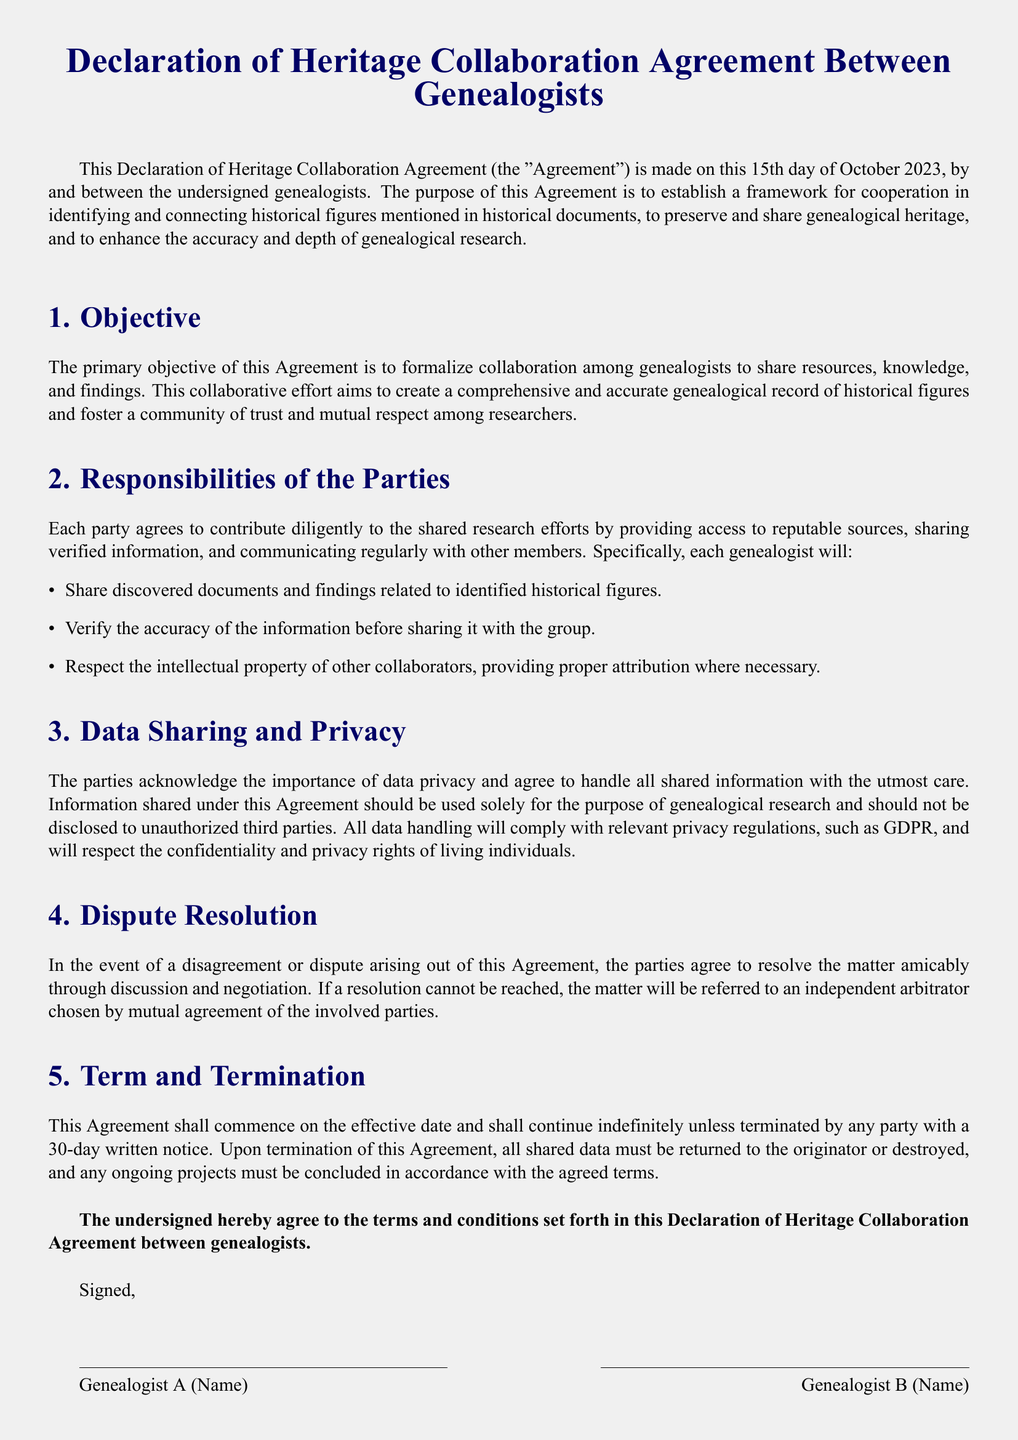What is the date of the Agreement? The date mentioned in the document indicates when the Agreement was made, which is the 15th of October 2023.
Answer: 15th day of October 2023 What is the primary objective of the Agreement? The primary objective as stated in the document is to formalize collaboration among genealogists.
Answer: formalize collaboration among genealogists How many responsibilities are listed under the responsibilities of the parties? The document outlines specific duties that each genealogist must follow, listed as several points.
Answer: three What must be done with shared data upon termination of the Agreement? The document specifies that all shared data must be either returned to the originator or destroyed.
Answer: returned to the originator or destroyed What kind of dispute resolution method is mentioned? The document provides a method for resolving disagreements through a specified process.
Answer: discussion and negotiation Which regulations must data handling comply with? The document notes a specific privacy regulation that must guide data handling and processing.
Answer: GDPR Who signs the Agreement? The Agreement requires names of involved parties to affirm their acceptance of the terms.
Answer: Genealogist A, B, C, and D What is the term duration of the Agreement? The document states the Agreement's duration and conditions for termination.
Answer: indefinite 